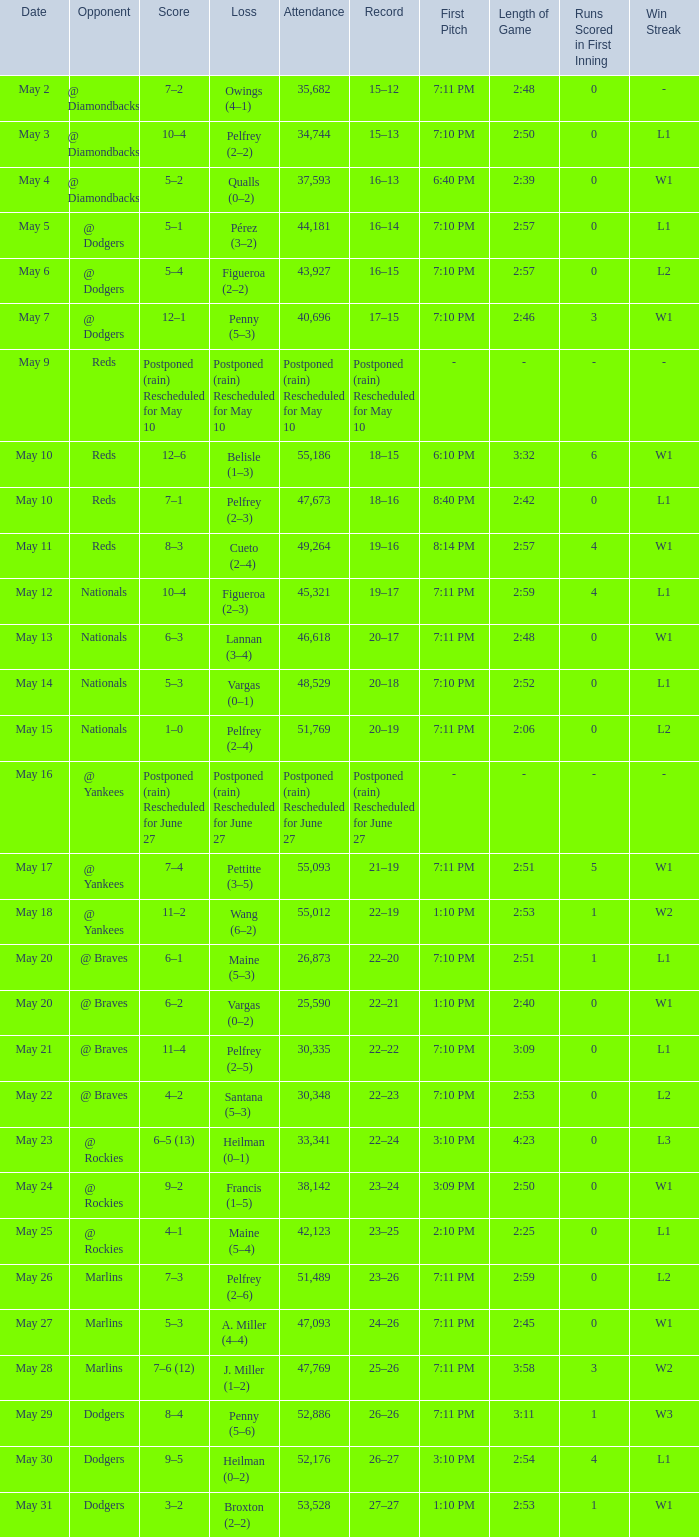Record of 22–20 involved what score? 6–1. 